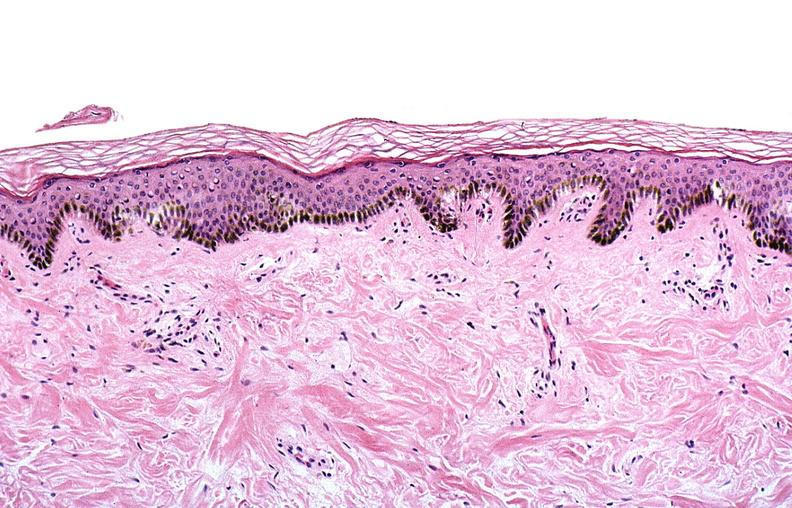does this image show thermal burned skin?
Answer the question using a single word or phrase. Yes 